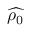Convert formula to latex. <formula><loc_0><loc_0><loc_500><loc_500>\widehat { \rho _ { 0 } }</formula> 